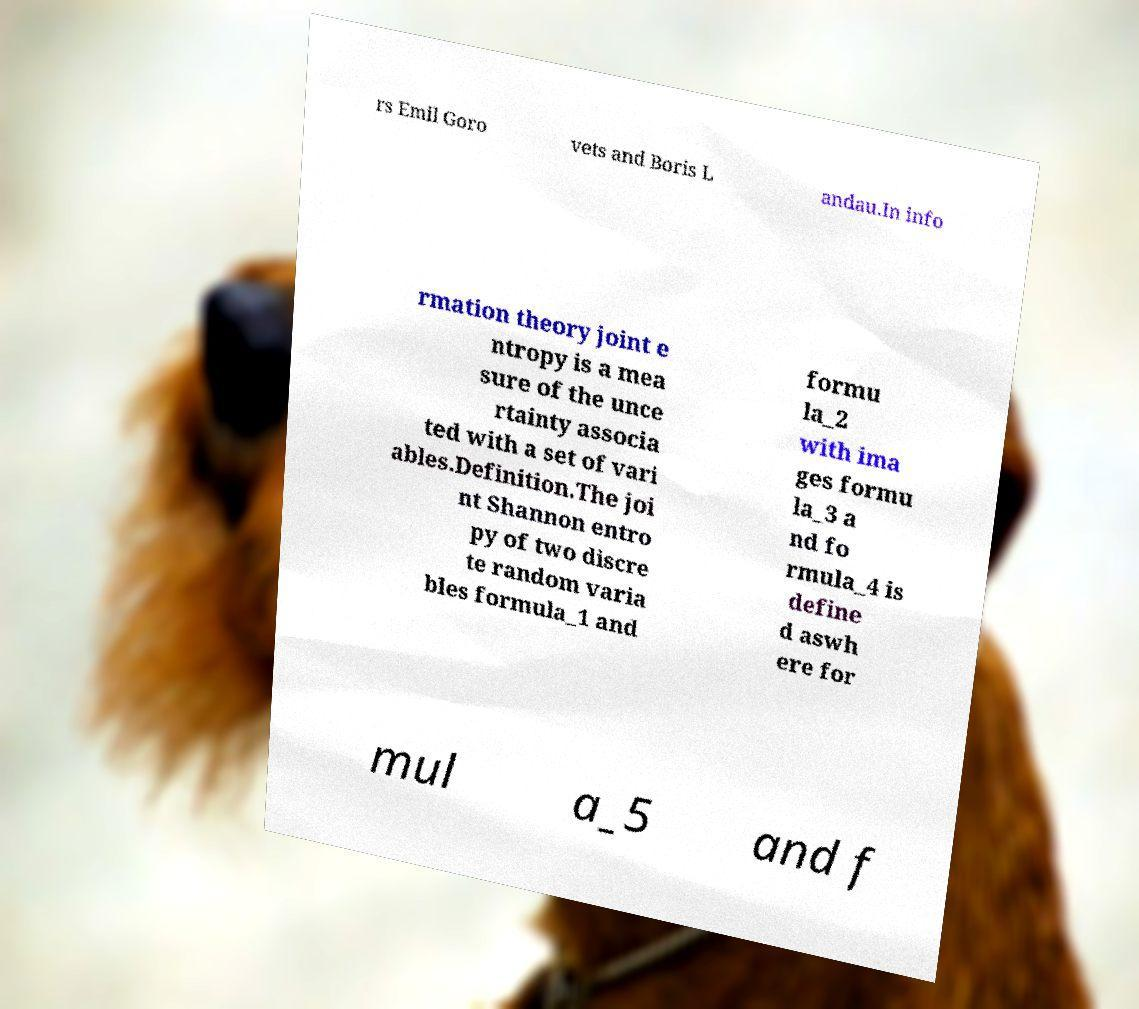Could you extract and type out the text from this image? rs Emil Goro vets and Boris L andau.In info rmation theory joint e ntropy is a mea sure of the unce rtainty associa ted with a set of vari ables.Definition.The joi nt Shannon entro py of two discre te random varia bles formula_1 and formu la_2 with ima ges formu la_3 a nd fo rmula_4 is define d aswh ere for mul a_5 and f 